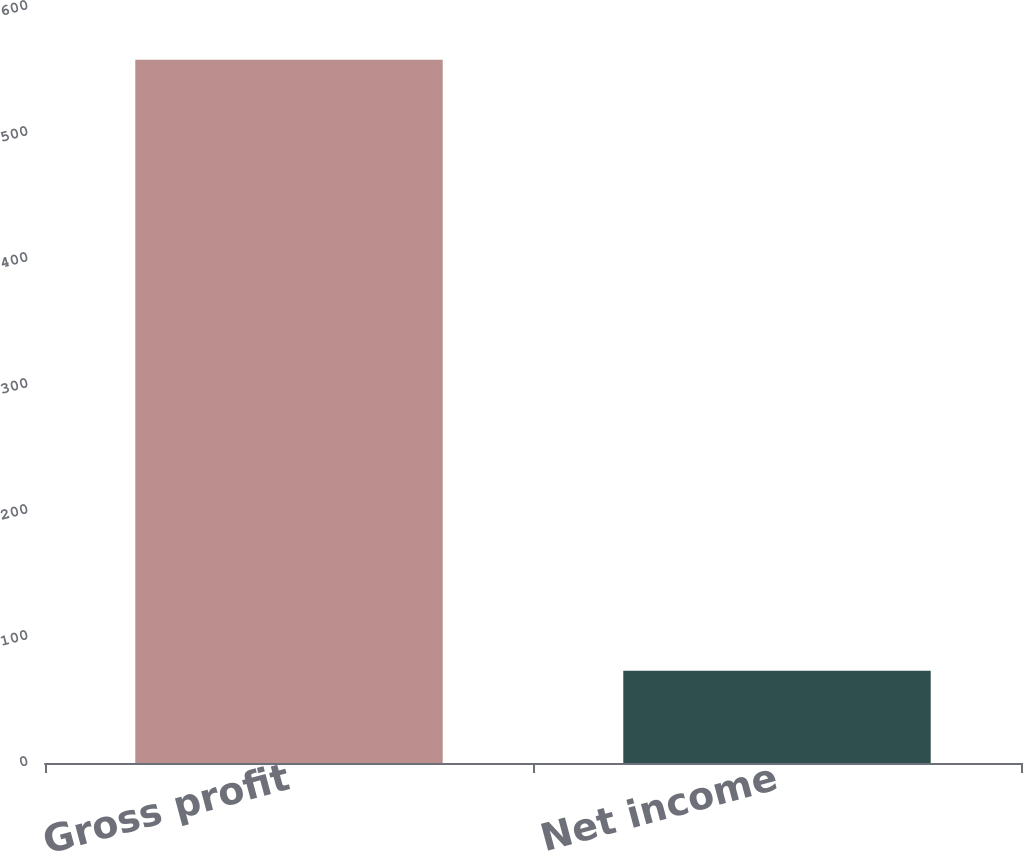Convert chart to OTSL. <chart><loc_0><loc_0><loc_500><loc_500><bar_chart><fcel>Gross profit<fcel>Net income<nl><fcel>558.1<fcel>73.2<nl></chart> 